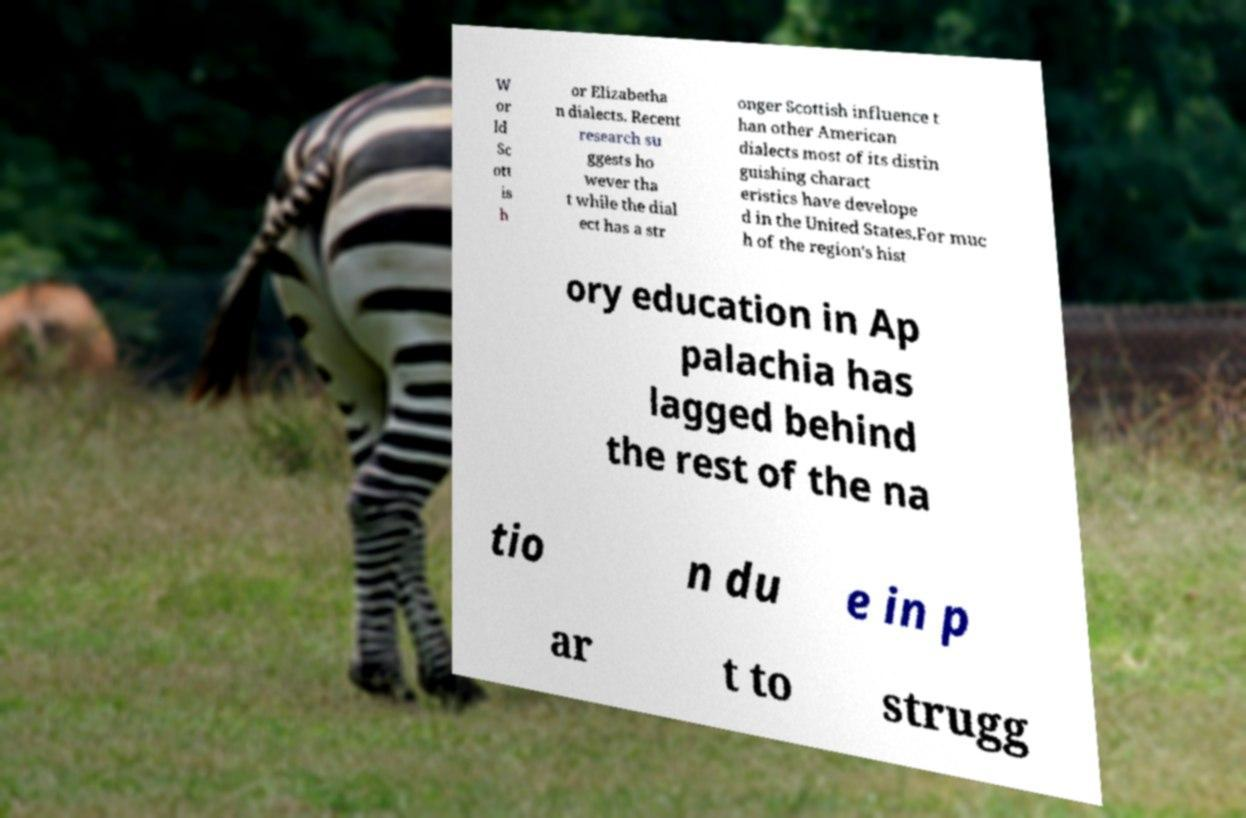For documentation purposes, I need the text within this image transcribed. Could you provide that? W or ld Sc ott is h or Elizabetha n dialects. Recent research su ggests ho wever tha t while the dial ect has a str onger Scottish influence t han other American dialects most of its distin guishing charact eristics have develope d in the United States.For muc h of the region's hist ory education in Ap palachia has lagged behind the rest of the na tio n du e in p ar t to strugg 